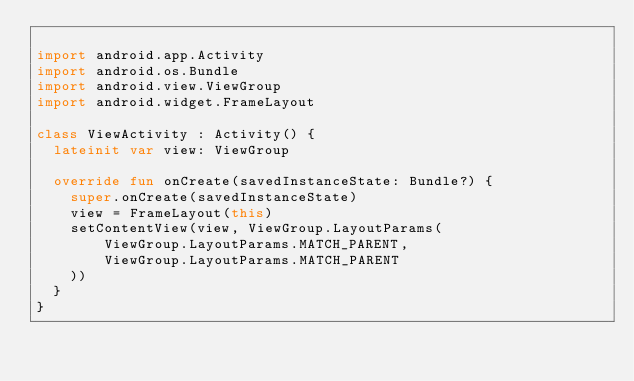Convert code to text. <code><loc_0><loc_0><loc_500><loc_500><_Kotlin_>
import android.app.Activity
import android.os.Bundle
import android.view.ViewGroup
import android.widget.FrameLayout

class ViewActivity : Activity() {
  lateinit var view: ViewGroup

  override fun onCreate(savedInstanceState: Bundle?) {
    super.onCreate(savedInstanceState)
    view = FrameLayout(this)
    setContentView(view, ViewGroup.LayoutParams(
        ViewGroup.LayoutParams.MATCH_PARENT,
        ViewGroup.LayoutParams.MATCH_PARENT
    ))
  }
}
</code> 